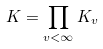<formula> <loc_0><loc_0><loc_500><loc_500>K = \prod _ { v < \infty } K _ { v }</formula> 